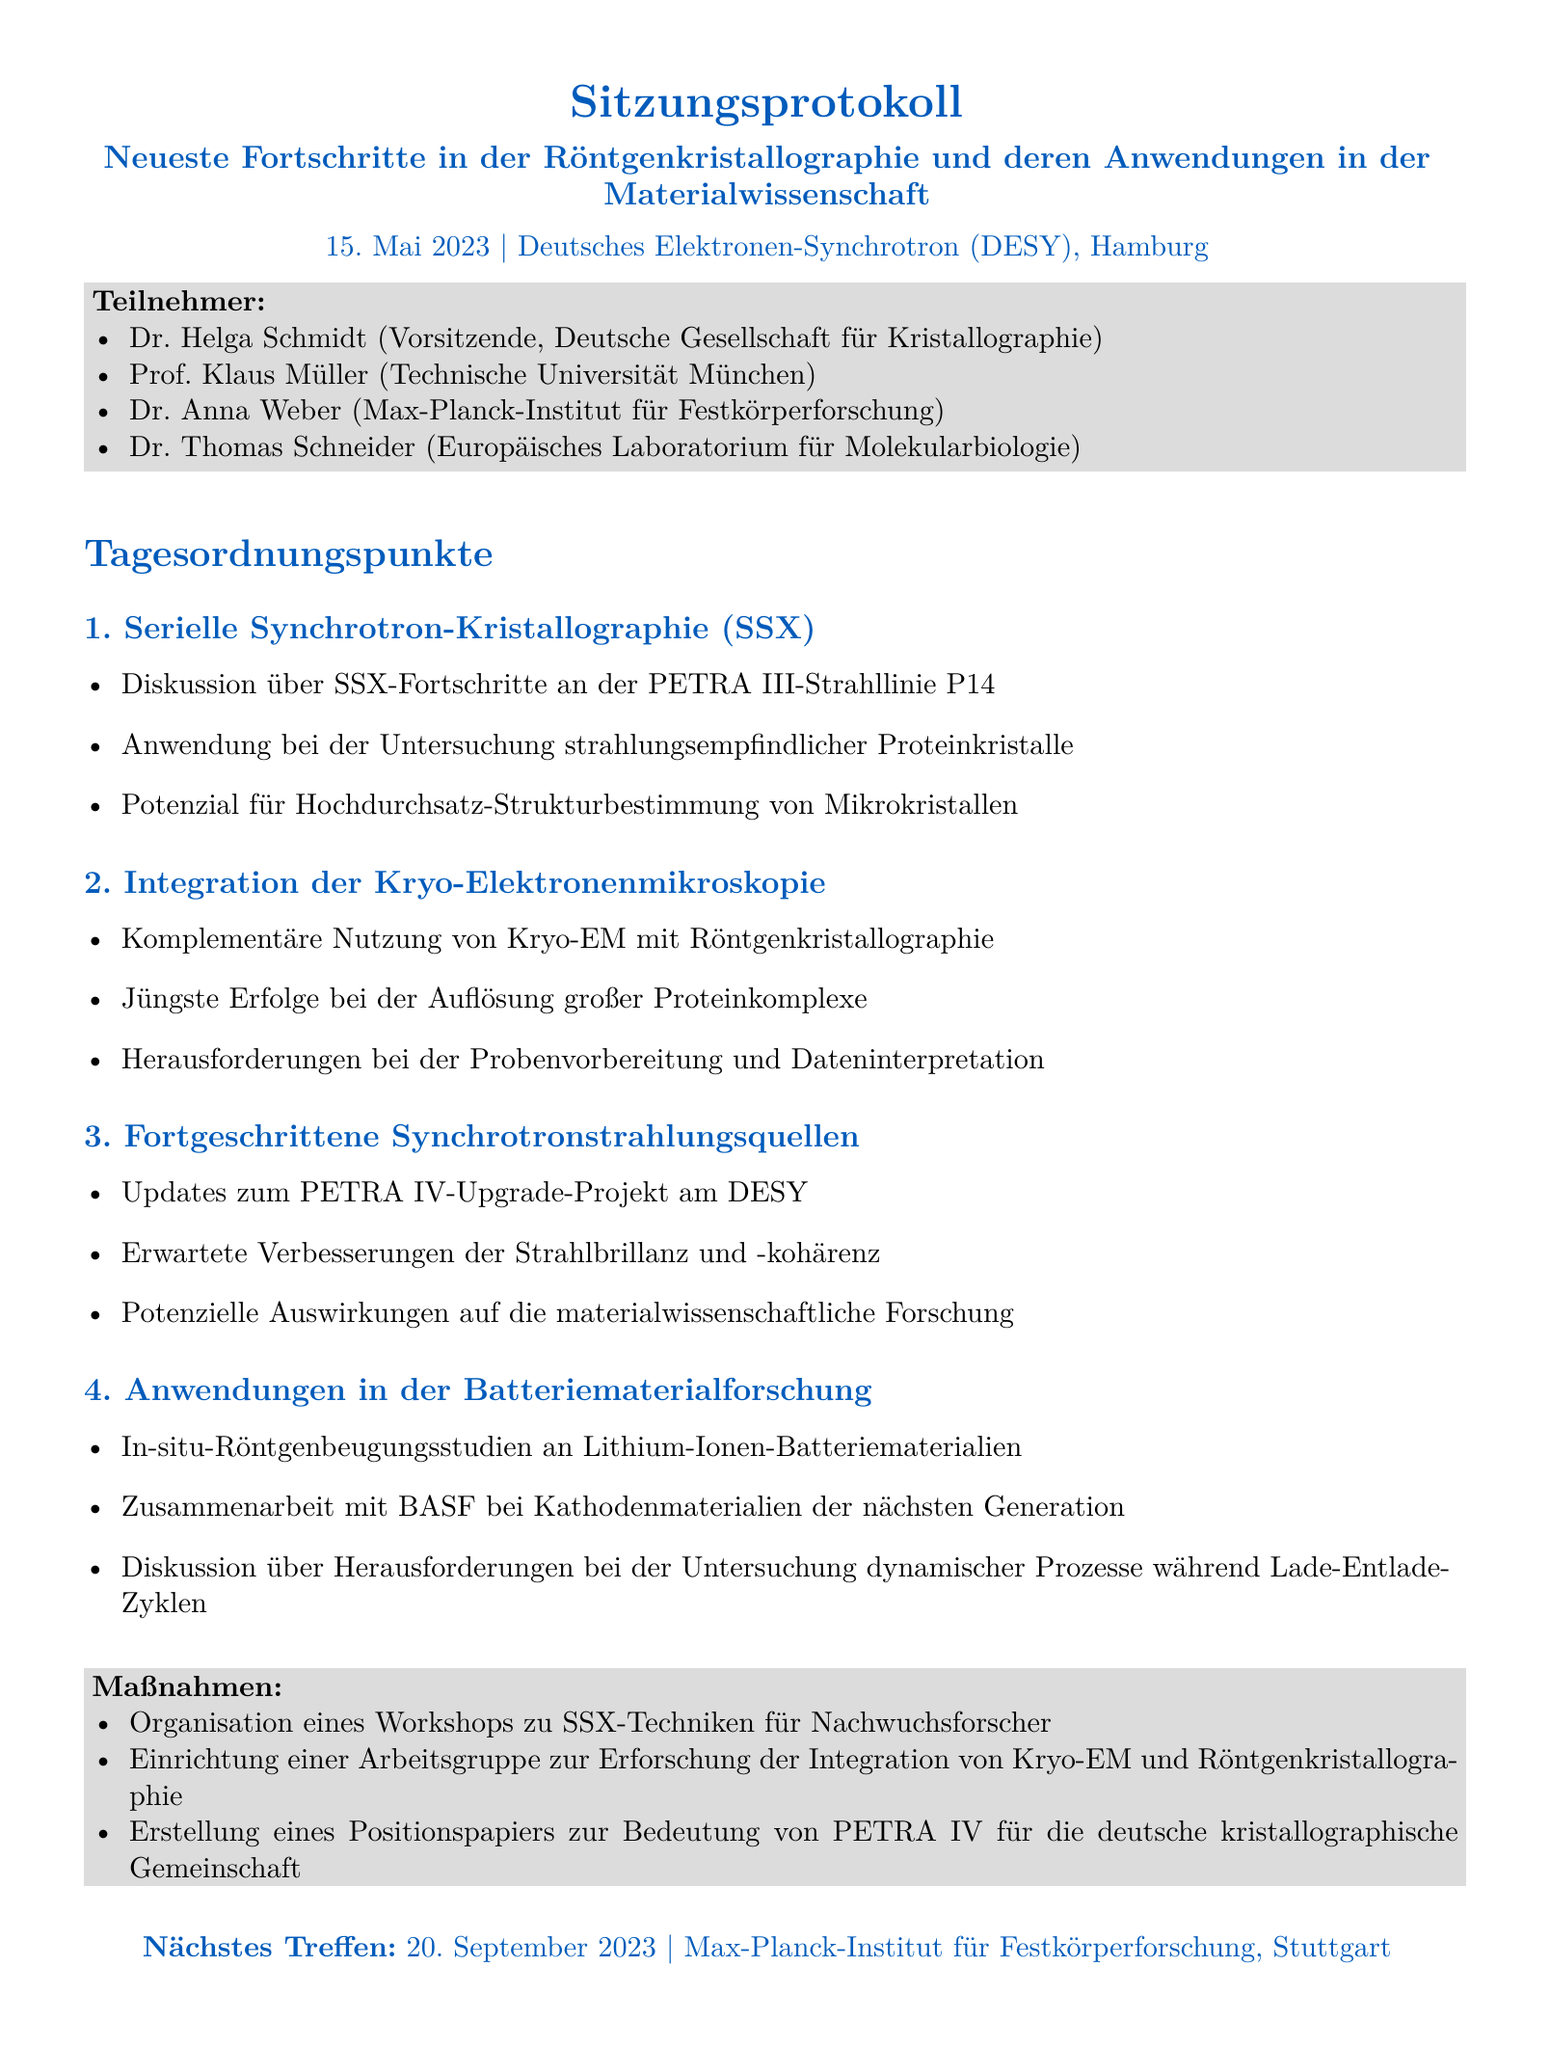Was war das Thema der Sitzung? Das Thema der Sitzung war die Diskussion über die neuesten Fortschritte in der Röntgenkristallographie und deren Anwendungen in der Materialwissenschaft.
Answer: Neueste Fortschritte in der Röntgenkristallographie und deren Anwendungen in der Materialwissenschaft Wer war der Vorsitzende der Sitzung? Der Vorsitzende der Sitzung war Dr. Helga Schmidt, die auch der Deutschen Gesellschaft für Kristallographie angehört.
Answer: Dr. Helga Schmidt An welchem Datum fand die Sitzung statt? Das Datum der Sitzung war der 15. Mai 2023.
Answer: 15. Mai 2023 Welche Technologie wurde bei der ersten Sitzung behandelt? Die erste Sitzung behandelte die serielle Synchrotron-Kristallographie (SSX).
Answer: Serielle Synchrotron-Kristallographie (SSX) Welches Projekt wurde im Zusammenhang mit PETRA IV angesprochen? Im Dokument wurde das Upgrade-Projekt PETRA IV erwähnt.
Answer: PETRA IV Upgrade-Projekt Wie viele Teilnehmer waren anwesend? Es waren vier Teilnehmer anwesend, die im Dokument aufgelistet sind.
Answer: vier Welches Unternehmen wurde in der Diskussion über Batteriematerialien erwähnt? BASF wurde in der Diskussion über die nächsten Generation von Kathodenmaterialien erwähnt.
Answer: BASF Was wird als Herausforderung bei der Kryo-EM Integration genannt? Die Herausforderung bei der Kryo-EM Integration sind die Probenvorbereitung und Dateninterpretation.
Answer: Probenvorbereitung und Dateninterpretation Wann und wo findet das nächste Treffen statt? Das nächste Treffen ist für den 20. September 2023 am Max-Planck-Institut für Festkörperforschung in Stuttgart geplant.
Answer: 20. September 2023, Max-Planck-Institut für Festkörperforschung, Stuttgart 